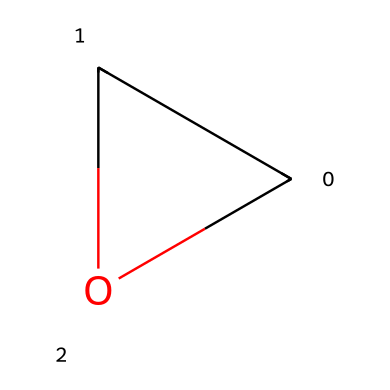What is the molecular formula of ethylene oxide? The molecular formula can be determined by counting the number of carbon (C), oxygen (O), and hydrogen (H) atoms from the SMILES structure. In C1CO1, there is one carbon atom, one oxygen atom, and two hydrogen atoms (in total). Therefore, the molecular formula is C2H4O when combined correctly.
Answer: C2H4O How many carbon atoms are in the structure? By examining the SMILES notation C1CO1, there is one representation of carbon in the ring along with an identified hydrogen bond, which constitutes the presence of one carbon atom.
Answer: 2 How many oxygen atoms are represented in the chemical structure? The SMILES notation C1CO1 has one "O" character which indicates the presence of one oxygen atom in the structure that contributes to its cyclic structure.
Answer: 1 What type of bonding exists in ethylene oxide? The presence of double bonds can be inferred from the structure in the given SMILES, where the carbon and oxygen are part of a three-membered ring, indicating the presence of covalent bonds.
Answer: covalent What is the general classification of ethylene oxide? Ethylene oxide is primarily used as a fumigant and sterilant in various processes. From the given SMILES structure, we understand it is a cyclic ether which separates it from other classes of chemicals.
Answer: cyclic ether What kind of structure does ethylene oxide have? The SMILES notation indicates a three-membered ring structure containing two carbon atoms and one oxygen atom, classifying it as a cyclic structure.
Answer: cyclic structure 